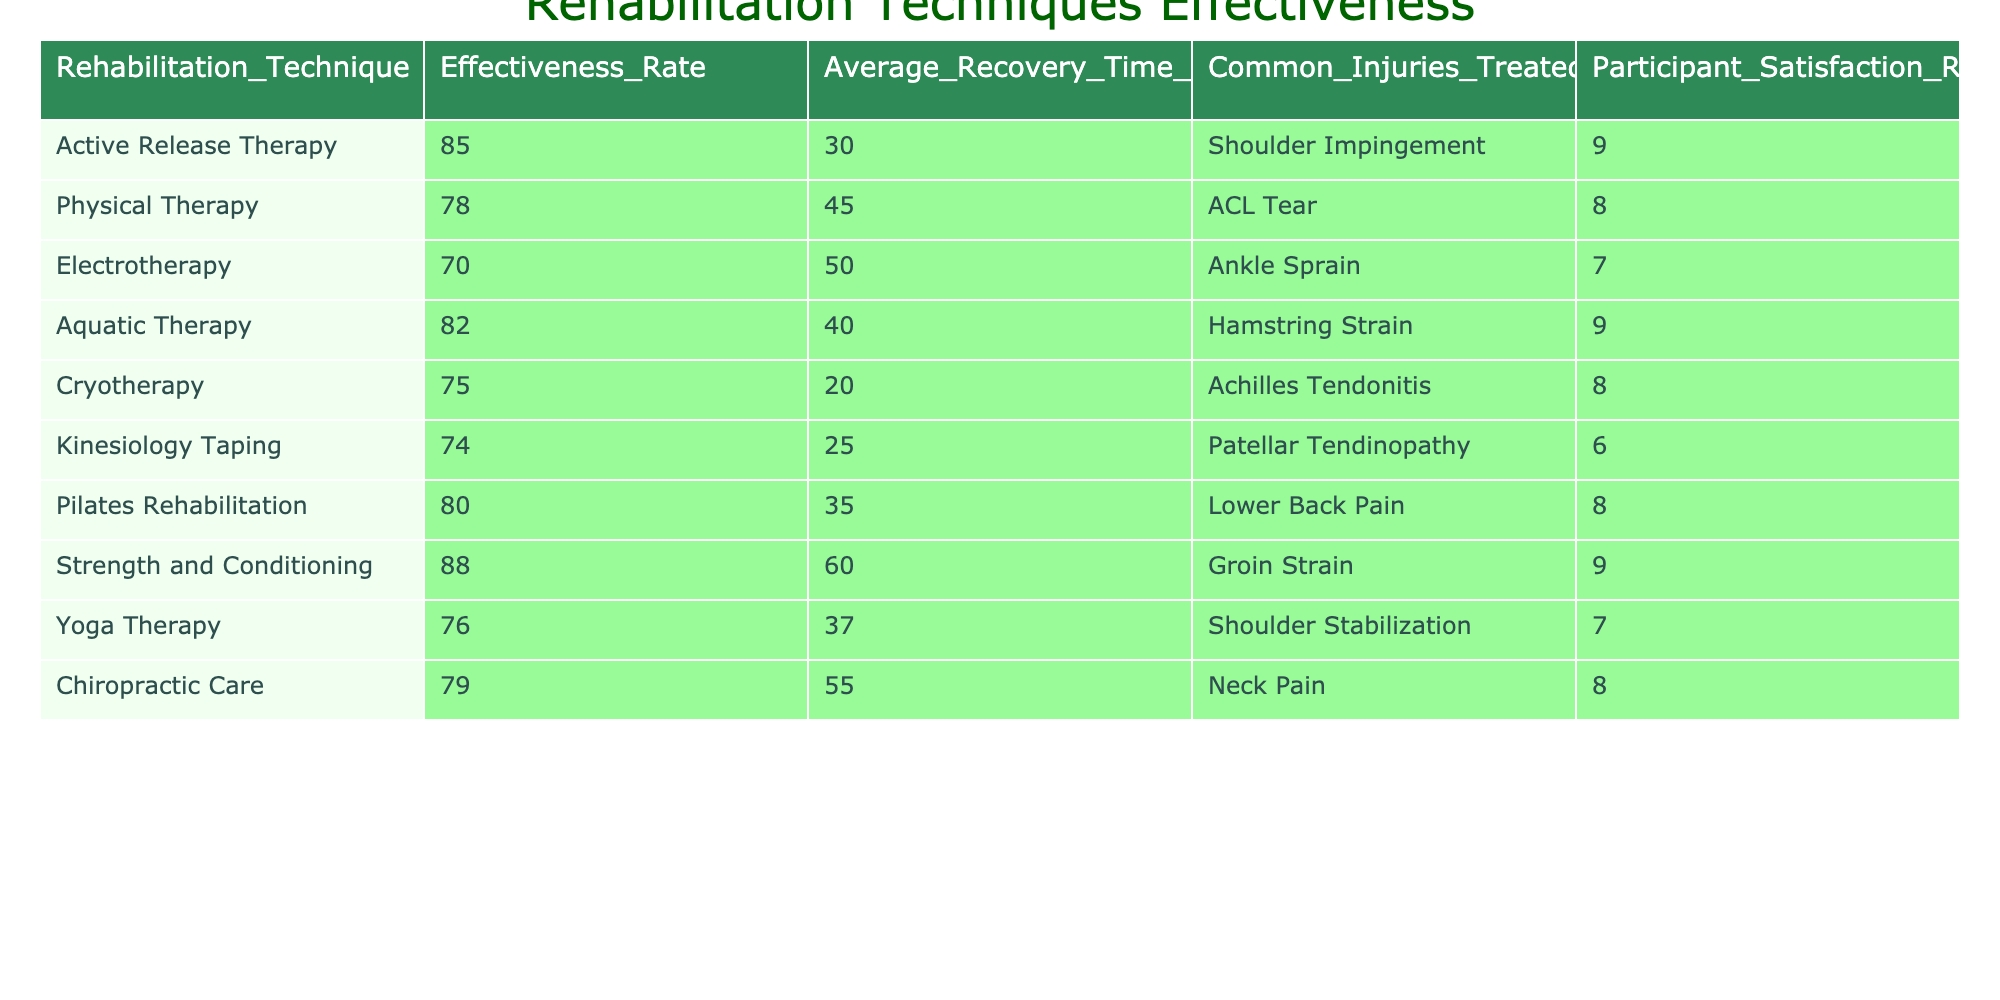What is the effectiveness rate of Pilates Rehabilitation? The table shows that the effectiveness rate for Pilates Rehabilitation is listed under the "Effectiveness Rate" column, where it states a value of 80.
Answer: 80 Which rehabilitation technique has the longest average recovery time? By comparing the "Average Recovery Time Days" values across the table, the longest value is 60 days for Strength and Conditioning.
Answer: 60 Is the average recovery time for Cryotherapy lesser than that for Aquatic Therapy? The average recovery time for Cryotherapy is listed as 20 days, while for Aquatic Therapy, it is 40 days. Since 20 is less than 40, the statement is true.
Answer: Yes What is the average effectiveness rate of Kinesiology Taping and Electrotherapy combined? Kinesiology Taping has an effectiveness rate of 74, and Electrotherapy has an effectiveness rate of 70. Adding these gives 144, and dividing by 2 to find the average gives us 72.
Answer: 72 Which technique has the highest participant satisfaction rating, and what is that rating? Looking through the "Participant Satisfaction Rating" column, both Active Release Therapy and Strength and Conditioning share the highest rating of 9.
Answer: 9 Does any rehabilitation technique have an effectiveness rate higher than 80% and an average recovery time less than 40 days? Checking the table, Active Release Therapy (85% effectiveness, 30 days) and Aquatic Therapy (82% effectiveness, 40 days) meet the effectiveness criterion, but Aquatic Therapy does not meet the recovery time criterion. Only Active Release Therapy meets both conditions.
Answer: Yes What is the total effectiveness rate for all rehabilitation techniques listed? Summing the effectiveness rates across all techniques yields 85 + 78 + 70 + 82 + 75 + 74 + 80 + 88 + 76 + 79 =  788.
Answer: 788 How many of the techniques have a participant satisfaction rating of 8 or higher? Counting the ratings of 8 or higher, we find Active Release Therapy, Aquatic Therapy, Pilates Rehabilitation, Strength and Conditioning, Chiropractic Care, which totals to 5 techniques.
Answer: 5 Which two rehabilitation techniques have the same effectiveness rate? The table exhibits Kinesiology Taping at 74 effectiveness and Electrotherapy at 70 effectiveness, but no two techniques share the same effectiveness rate.
Answer: None 